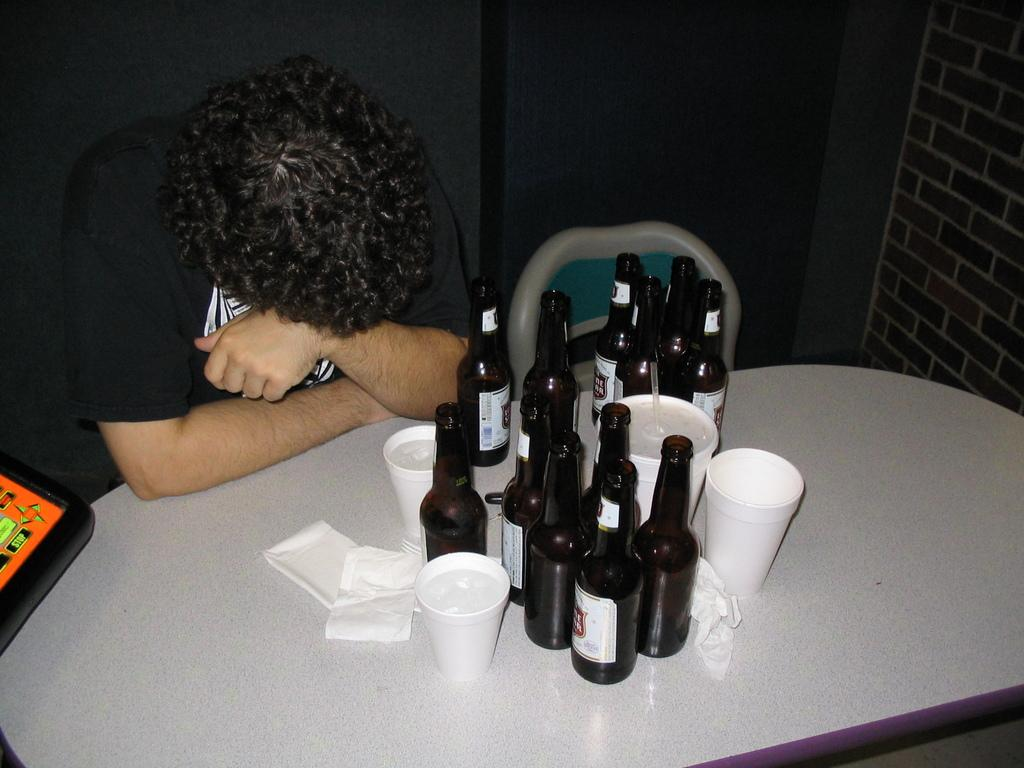What type of structure is visible in the image? There is a brick wall in the image. Can you describe the person in the image? There is a person wearing a black t-shirt in the image. What piece of furniture is present in the image? There is a table in the image. What items are on the table? Tissues, glasses, and bottles are on the table. What type of ship is visible in the image? There is no ship present in the image; it features a brick wall, a person, a table, and various items on the table. How many parcels are on the table in the image? There are no parcels present in the image; it features tissues, glasses, and bottles on the table. 